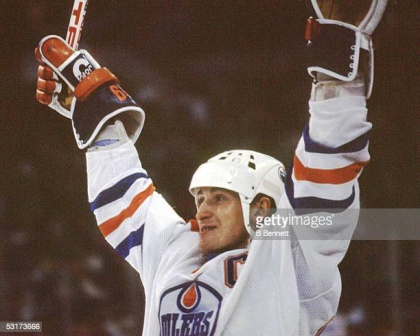Imagine a creative backstory for this player. Once upon a frozen rink, there was a young boy named Alex who grew up in a quaint Canadian town known for its love of hockey. From the moment he could walk, Alex was mesmerized by the sport. He would often sneak into the local rink, spending hours practicing his shots and imagining the roar of the crowd.

Years passed, and Alex's passion for hockey only deepened. Despite facing numerous setbacks, including a severe injury that almost ended his career, his determination never wavered. With the support of his family and community, Alex made a triumphant return to the ice.

This image captures Alex's ultimate moment of glory. After clinching the winning goal in the championship game, he raises his arms in a heartfelt tribute to everyone who believed in him. This moment is not just about a game; it symbolizes a journey filled with perseverance, hope, and an unyielding spirit. If you could write a short poem inspired by this image, what would it be? In the icy glow of the spotlight's shine,
A hero's heart crosses the victory line.
With sticks and gloves raised to the sky,
He answers the long-awaited cry.
Through trials, tears, and endless fight,
He basks in the glory of tonight.
A moment frozen in time's embrace,
The triumph of his steadfast race. 